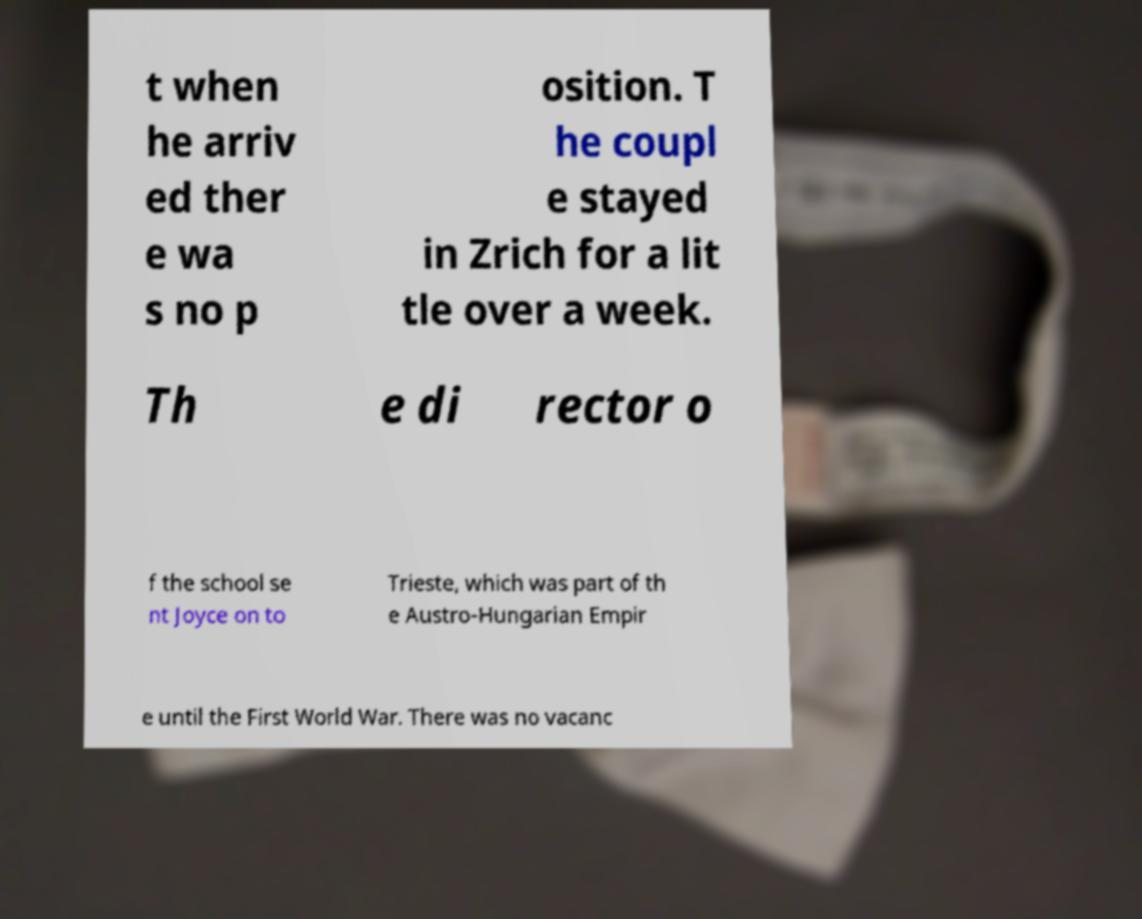Could you assist in decoding the text presented in this image and type it out clearly? t when he arriv ed ther e wa s no p osition. T he coupl e stayed in Zrich for a lit tle over a week. Th e di rector o f the school se nt Joyce on to Trieste, which was part of th e Austro-Hungarian Empir e until the First World War. There was no vacanc 